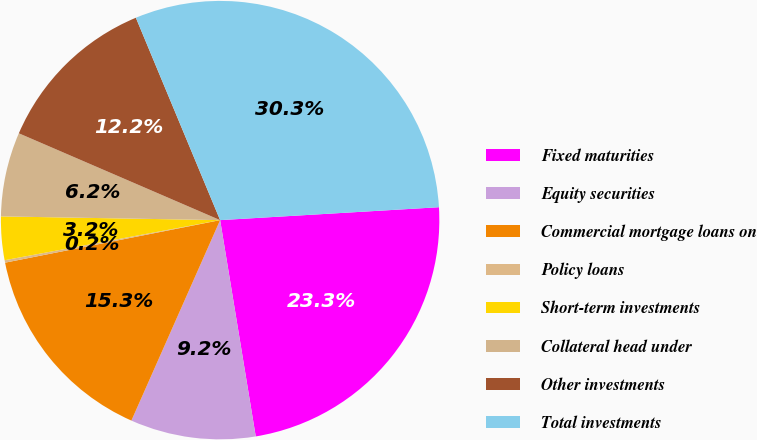<chart> <loc_0><loc_0><loc_500><loc_500><pie_chart><fcel>Fixed maturities<fcel>Equity securities<fcel>Commercial mortgage loans on<fcel>Policy loans<fcel>Short-term investments<fcel>Collateral head under<fcel>Other investments<fcel>Total investments<nl><fcel>23.34%<fcel>9.23%<fcel>15.26%<fcel>0.18%<fcel>3.2%<fcel>6.21%<fcel>12.24%<fcel>30.34%<nl></chart> 